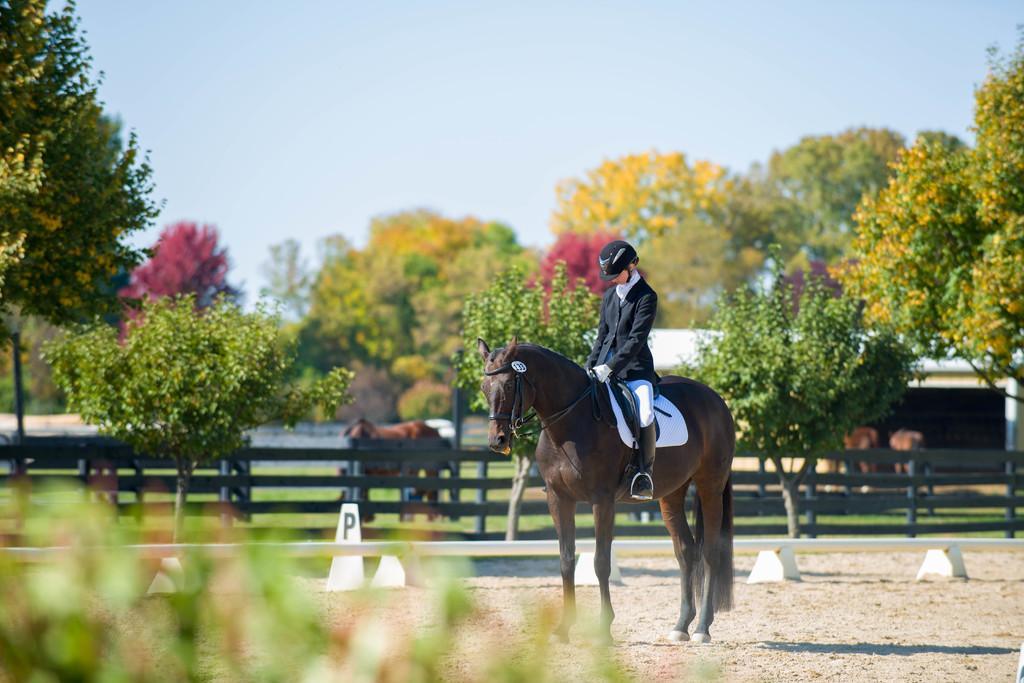Describe this image in one or two sentences. In the center of the image we can see a person is sitting on a horse and wearing a hat. In the middle of the image we can see fencing, horses, trees, house are present. At the top of the image sky is there. At the bottom of the image ground is there. In the middle of the image grass is there. 